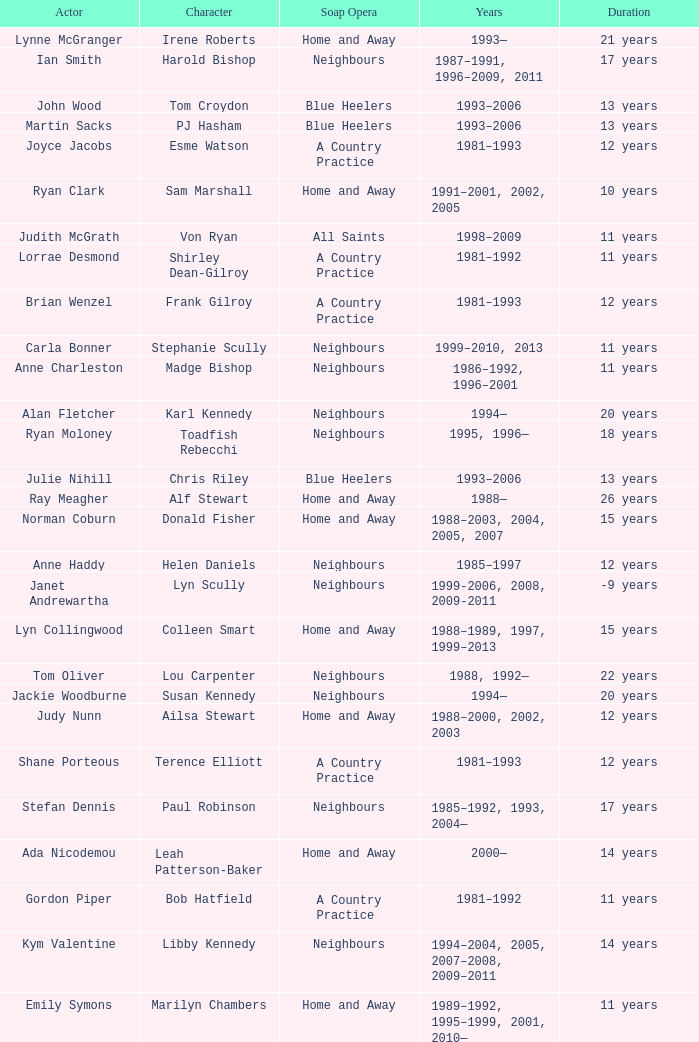What character was portrayed by the same actor for 12 years on Neighbours? Helen Daniels. 